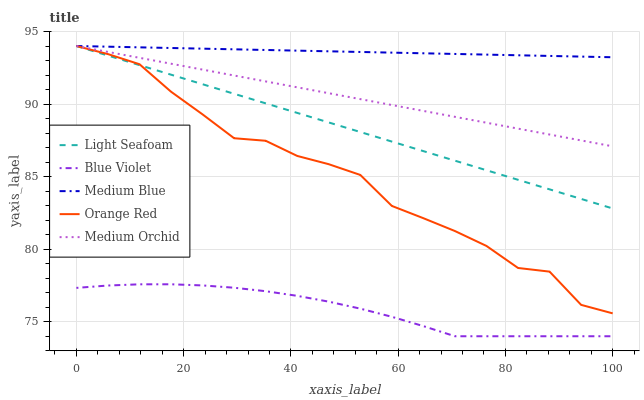Does Blue Violet have the minimum area under the curve?
Answer yes or no. Yes. Does Medium Blue have the maximum area under the curve?
Answer yes or no. Yes. Does Light Seafoam have the minimum area under the curve?
Answer yes or no. No. Does Light Seafoam have the maximum area under the curve?
Answer yes or no. No. Is Medium Orchid the smoothest?
Answer yes or no. Yes. Is Orange Red the roughest?
Answer yes or no. Yes. Is Light Seafoam the smoothest?
Answer yes or no. No. Is Light Seafoam the roughest?
Answer yes or no. No. Does Blue Violet have the lowest value?
Answer yes or no. Yes. Does Light Seafoam have the lowest value?
Answer yes or no. No. Does Orange Red have the highest value?
Answer yes or no. Yes. Does Blue Violet have the highest value?
Answer yes or no. No. Is Blue Violet less than Medium Blue?
Answer yes or no. Yes. Is Orange Red greater than Blue Violet?
Answer yes or no. Yes. Does Medium Blue intersect Orange Red?
Answer yes or no. Yes. Is Medium Blue less than Orange Red?
Answer yes or no. No. Is Medium Blue greater than Orange Red?
Answer yes or no. No. Does Blue Violet intersect Medium Blue?
Answer yes or no. No. 